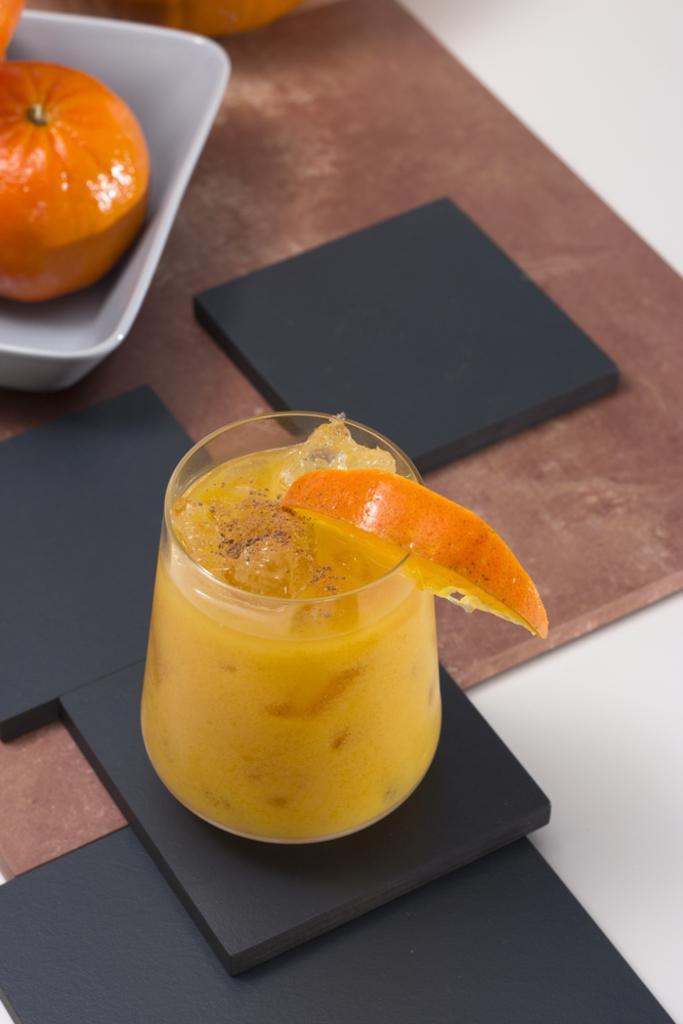Can you describe this image briefly? There is a white surface. On that there is a wooden board. On that there are black items. Also there is a tray with fruits. And there is a glass with juice. On the glass there is a slice of orange. 